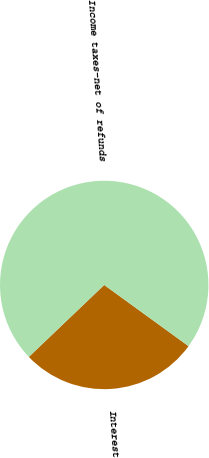<chart> <loc_0><loc_0><loc_500><loc_500><pie_chart><fcel>Interest<fcel>Income taxes-net of refunds<nl><fcel>27.88%<fcel>72.12%<nl></chart> 